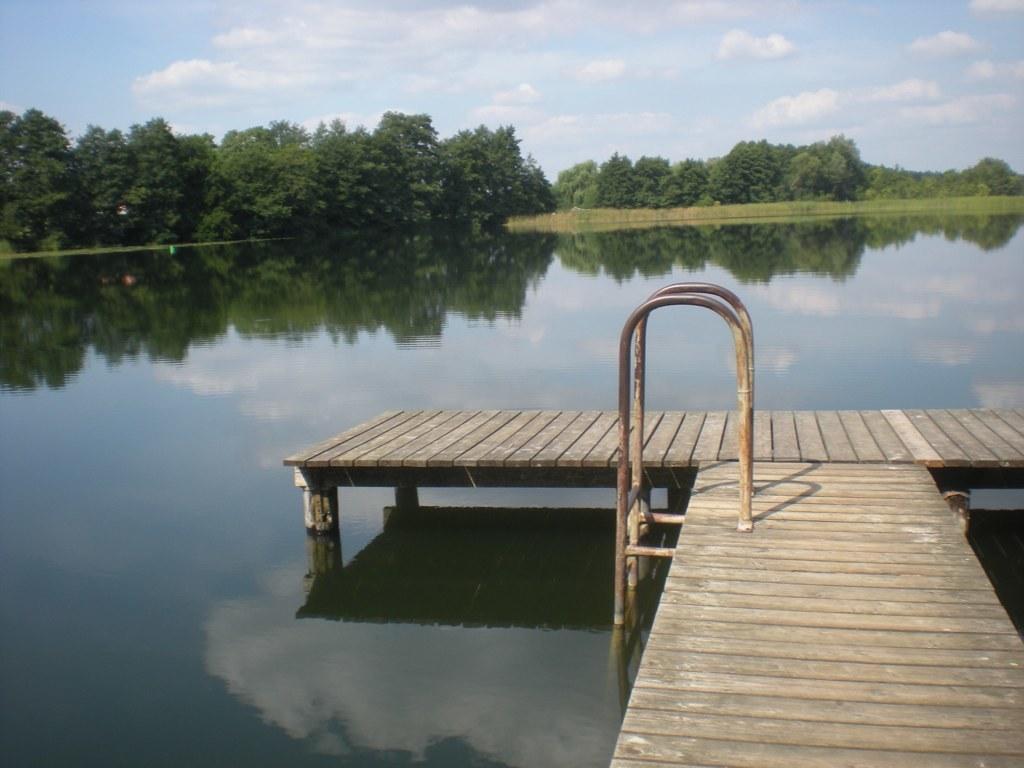Can you describe this image briefly? In this picture I can see a wooden pier, a step pool ladder, water, trees, and in the background there is sky. 